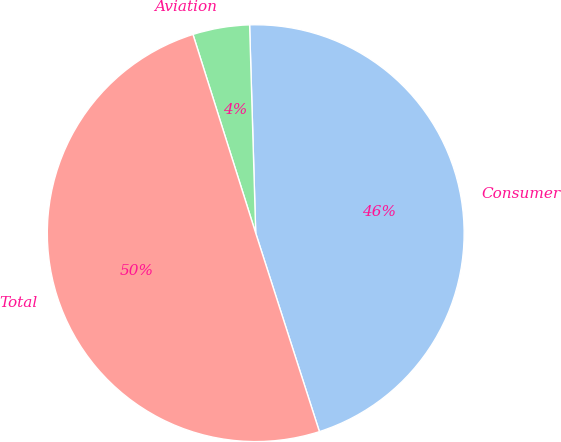<chart> <loc_0><loc_0><loc_500><loc_500><pie_chart><fcel>Consumer<fcel>Aviation<fcel>Total<nl><fcel>45.53%<fcel>4.4%<fcel>50.08%<nl></chart> 